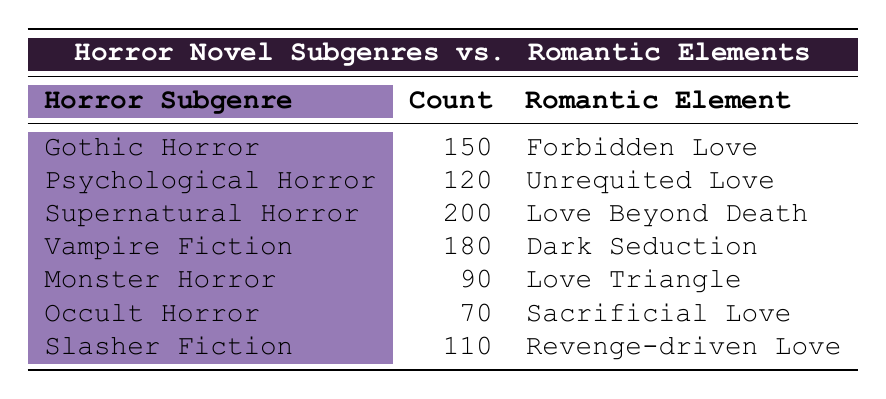What's the most popular horror subgenre based on the counts? The counts are highest for 'Supernatural Horror' with 200, higher than any other subgenre listed.
Answer: Supernatural Horror Which romantic element is associated with 'Vampire Fiction'? By looking at the table, 'Vampire Fiction' has 'Dark Seduction' listed as its romantic element.
Answer: Dark Seduction How many horror subgenres have a count greater than 150? The subgenres with counts greater than 150 are 'Supernatural Horror' (200), 'Vampire Fiction' (180), and 'Gothic Horror' (150). So, that totals to 2 subgenres above 150 when not counting Gothic Horror.
Answer: 2 What is the total count of all subgenres that involve romantic elements associated with sacrifice? The only subgenre related to sacrifice is 'Occult Horror' with a count of 70.
Answer: 70 Is 'Forbidden Love' the romantic element for 'Psychological Horror'? The table has 'Forbidden Love' for 'Gothic Horror' and 'Unrequited Love' for 'Psychological Horror', so the statement is false.
Answer: No Which horror subgenre has the least count? The least count in the table is for 'Occult Horror', which has a count of 70, the lowest among all subgenres.
Answer: Occult Horror What is the difference in count between 'Slasher Fiction' and 'Monster Horror'? 'Slasher Fiction' has a count of 110 while 'Monster Horror' has 90, giving a difference of 110 - 90 = 20.
Answer: 20 How many romantic elements are listed in total? There are distinct romantic elements listed for seven subgenres in the table, counting each one without repeats.
Answer: 7 Which romantic element correlates with the highest horror subgenre count? The romantic element 'Love Beyond Death' correlates with 'Supernatural Horror', which has the highest count of 200.
Answer: Love Beyond Death 